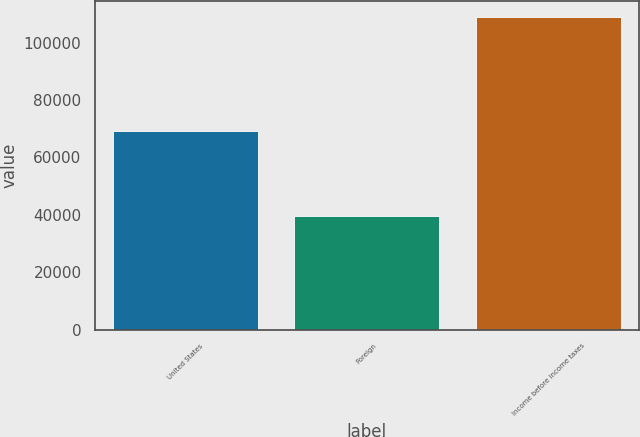Convert chart. <chart><loc_0><loc_0><loc_500><loc_500><bar_chart><fcel>United States<fcel>Foreign<fcel>Income before income taxes<nl><fcel>69343<fcel>39685<fcel>109028<nl></chart> 